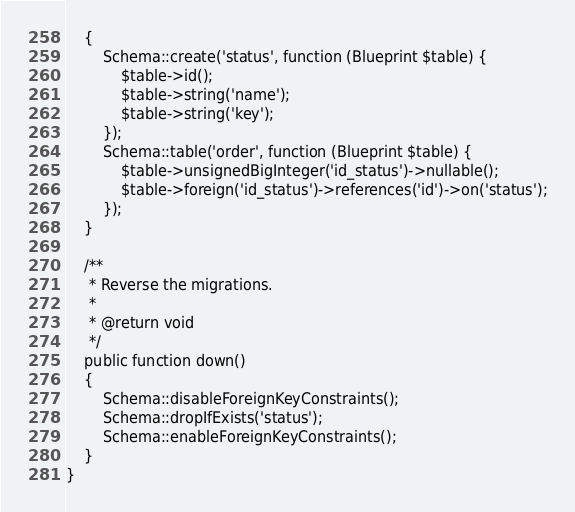Convert code to text. <code><loc_0><loc_0><loc_500><loc_500><_PHP_>    {
        Schema::create('status', function (Blueprint $table) {
            $table->id();
            $table->string('name');
            $table->string('key');
        });
        Schema::table('order', function (Blueprint $table) {
            $table->unsignedBigInteger('id_status')->nullable();
            $table->foreign('id_status')->references('id')->on('status');
        });
    }

    /**
     * Reverse the migrations.
     *
     * @return void
     */
    public function down()
    {
        Schema::disableForeignKeyConstraints();
        Schema::dropIfExists('status');
        Schema::enableForeignKeyConstraints();
    }
}
</code> 